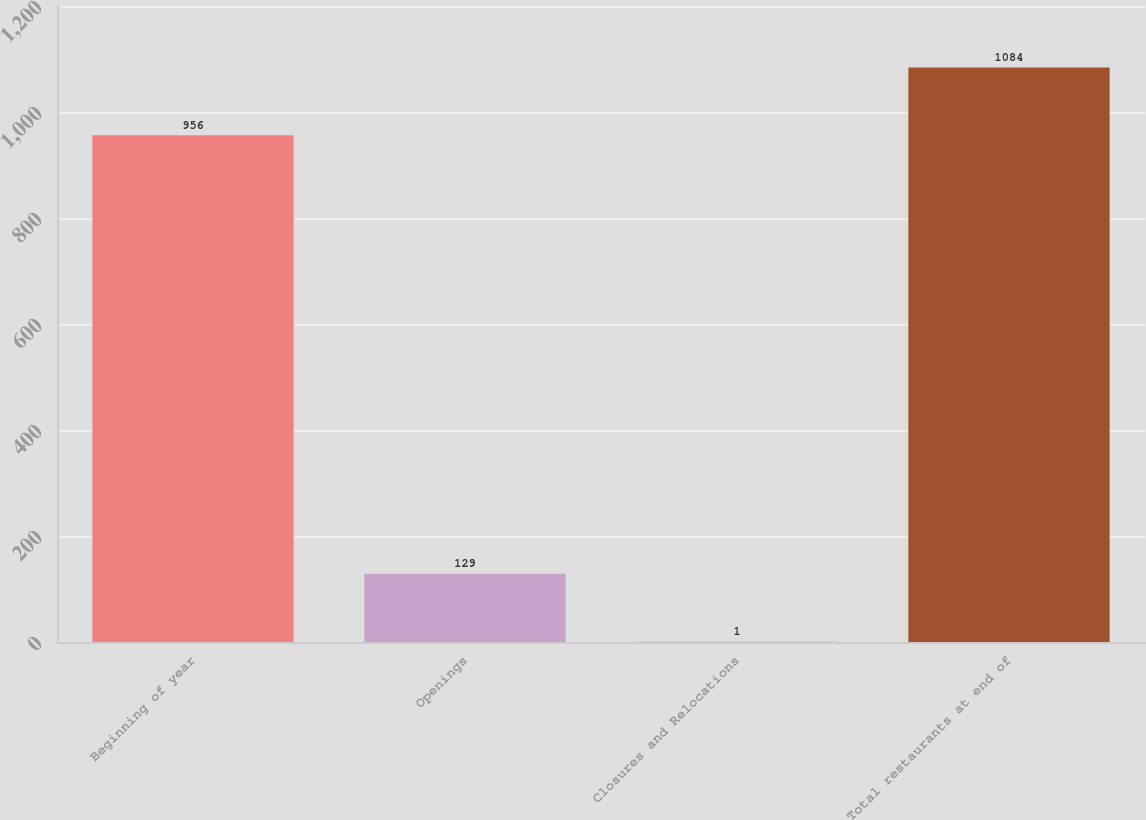Convert chart. <chart><loc_0><loc_0><loc_500><loc_500><bar_chart><fcel>Beginning of year<fcel>Openings<fcel>Closures and Relocations<fcel>Total restaurants at end of<nl><fcel>956<fcel>129<fcel>1<fcel>1084<nl></chart> 